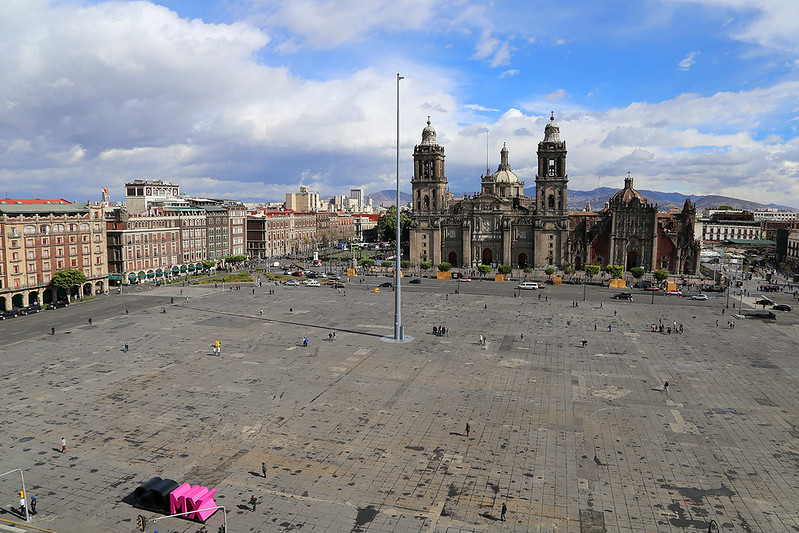Describe the following image. The image features an expansive aerial view of the Zócalo, the main square in Mexico City, showcasing its grand scale and cultural significance. Directly in view is the Metropolitan Cathedral, an iconic structure with impressive architectural details reflecting its colonial past. The square is sparsely populated, which might suggest a calm day or a moment captured outside usual peak hours. Surrounding the square are various historical buildings with robust facades in shades of gray and brown, witnessing the city's rich heritage and bustling urban life. Above, the sky is clear with minimal clouds, illuminating the area with natural light that highlights the vibrant yet orderly atmosphere of this historic location. Additional elements such as the minimal vendor presence could point to the local economy and the role of tourism in the area. This place is not just a tourist attraction but a central hub for cultural events and political gatherings, making it a vital part of Mexico City's identity. 